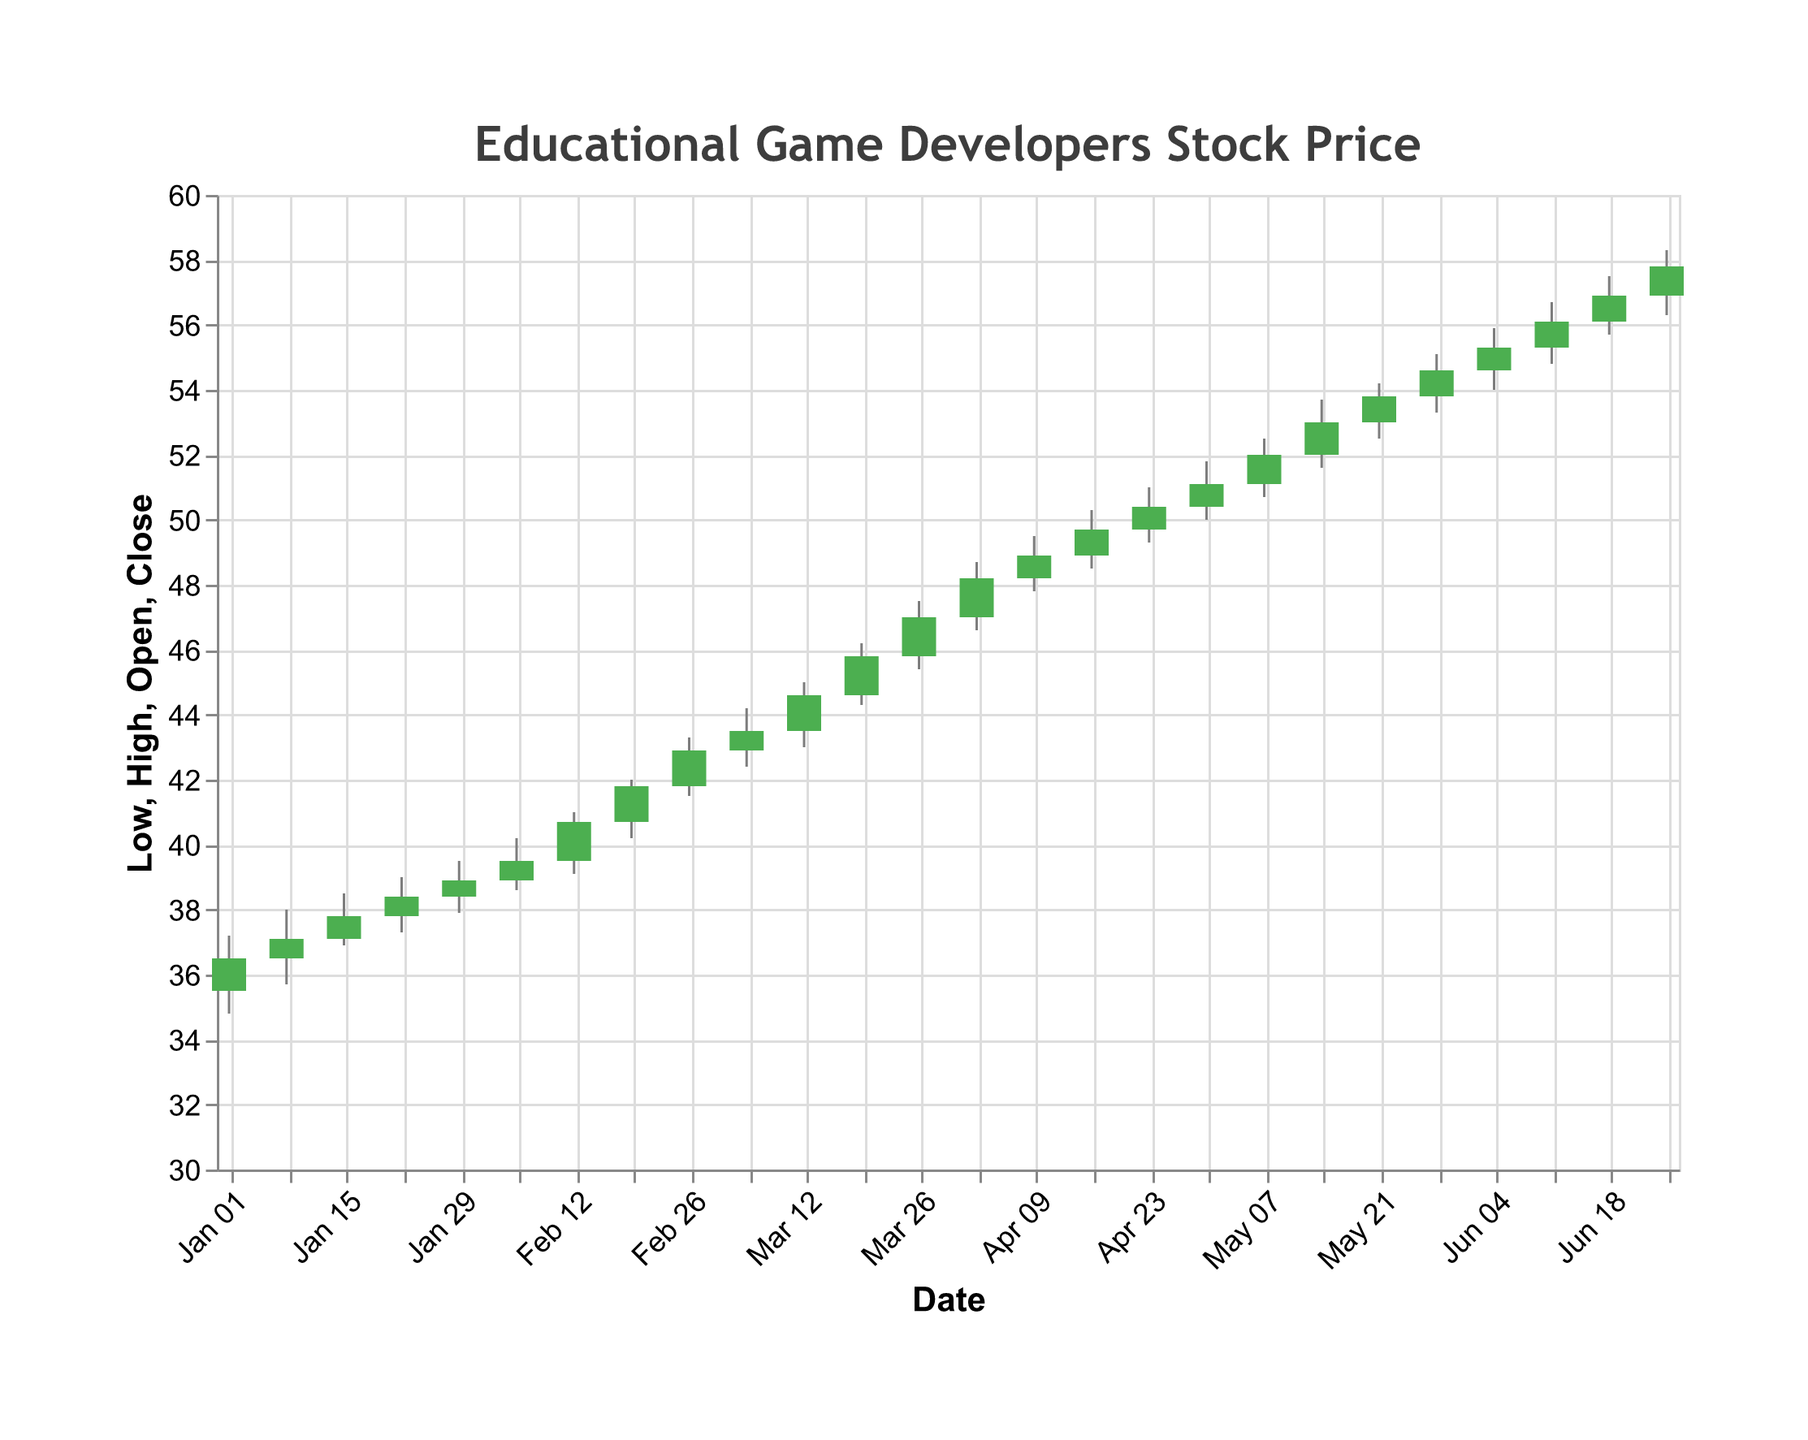What is the title of the figure? The title is located at the top of the figure and reads "Educational Game Developers Stock Price".
Answer: Educational Game Developers Stock Price What color is used for a candlestick bar when the closing price is higher than the opening price? When the closing price is higher than the opening price, the candlestick bar is green.
Answer: Green How many data points (weeks) are displayed in the figure? By counting the candlestick bars in the figure, we can see there are data points for 26 weeks.
Answer: 26 What is the difference between the highest and lowest stock price observed in the figure? The highest stock price observed is 58.3 (high on June 25, 2023) and the lowest is 34.8 (low on January 1, 2023). The difference is 58.3 - 34.8 = 23.5.
Answer: 23.5 What is the average closing price for the first four weeks in January 2023? Sum up the closing prices for the first four weeks: 36.5 + 37.1 + 37.8 + 38.4 = 149.8. Divide by 4 to get the average: 149.8 / 4 = 37.45.
Answer: 37.45 Which week shows the highest closing price, and what is that price? By inspecting the closing prices in the figure, the highest closing price is observed on June 25, 2023, with a closing price of 57.8.
Answer: June 25, 2023, 57.8 In which week did the stock price have the largest single-week increase? By comparing week-to-week closing prices, the largest increase is from May 14, 2023 (53.0) to May 21, 2023 (53.8), an increase of 0.8.
Answer: May 21, 2023 During which week did the stock price open at the highest price? The highest opening price is seen during the week of June 25, 2023, with an opening price of 56.9.
Answer: June 25, 2023 What is the pattern of the stock trend from January to June in this data set? Observing the closing prices over the months, there is a steady upward trend from January (36.5) to June (57.8).
Answer: Upward trend During which week in February did the stock price reach its highest point, and what was the high? By looking at the highs in February, the highest point was reached on February 26, 2023, with a high of 43.3.
Answer: February 26, 2023, 43.3 